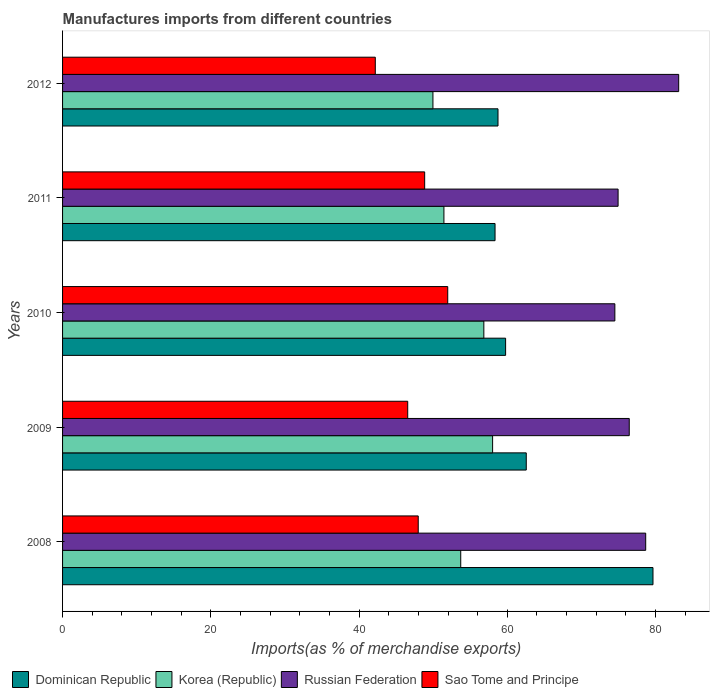How many groups of bars are there?
Make the answer very short. 5. How many bars are there on the 2nd tick from the top?
Make the answer very short. 4. How many bars are there on the 4th tick from the bottom?
Keep it short and to the point. 4. What is the label of the 2nd group of bars from the top?
Offer a terse response. 2011. In how many cases, is the number of bars for a given year not equal to the number of legend labels?
Offer a very short reply. 0. What is the percentage of imports to different countries in Korea (Republic) in 2012?
Ensure brevity in your answer.  49.97. Across all years, what is the maximum percentage of imports to different countries in Sao Tome and Principe?
Provide a short and direct response. 51.97. Across all years, what is the minimum percentage of imports to different countries in Russian Federation?
Make the answer very short. 74.51. In which year was the percentage of imports to different countries in Sao Tome and Principe maximum?
Ensure brevity in your answer.  2010. In which year was the percentage of imports to different countries in Korea (Republic) minimum?
Offer a terse response. 2012. What is the total percentage of imports to different countries in Korea (Republic) in the graph?
Provide a short and direct response. 269.99. What is the difference between the percentage of imports to different countries in Russian Federation in 2009 and that in 2010?
Your answer should be very brief. 1.94. What is the difference between the percentage of imports to different countries in Russian Federation in 2011 and the percentage of imports to different countries in Dominican Republic in 2008?
Give a very brief answer. -4.71. What is the average percentage of imports to different countries in Russian Federation per year?
Offer a very short reply. 77.54. In the year 2009, what is the difference between the percentage of imports to different countries in Korea (Republic) and percentage of imports to different countries in Sao Tome and Principe?
Offer a terse response. 11.45. What is the ratio of the percentage of imports to different countries in Dominican Republic in 2011 to that in 2012?
Provide a succinct answer. 0.99. What is the difference between the highest and the second highest percentage of imports to different countries in Dominican Republic?
Your answer should be compact. 17.1. What is the difference between the highest and the lowest percentage of imports to different countries in Korea (Republic)?
Your answer should be compact. 8.05. What does the 2nd bar from the top in 2011 represents?
Your answer should be compact. Russian Federation. What does the 3rd bar from the bottom in 2011 represents?
Your answer should be compact. Russian Federation. What is the difference between two consecutive major ticks on the X-axis?
Keep it short and to the point. 20. Are the values on the major ticks of X-axis written in scientific E-notation?
Your answer should be very brief. No. Does the graph contain any zero values?
Ensure brevity in your answer.  No. How many legend labels are there?
Provide a short and direct response. 4. What is the title of the graph?
Your answer should be very brief. Manufactures imports from different countries. What is the label or title of the X-axis?
Give a very brief answer. Imports(as % of merchandise exports). What is the label or title of the Y-axis?
Offer a terse response. Years. What is the Imports(as % of merchandise exports) of Dominican Republic in 2008?
Offer a very short reply. 79.66. What is the Imports(as % of merchandise exports) in Korea (Republic) in 2008?
Give a very brief answer. 53.72. What is the Imports(as % of merchandise exports) of Russian Federation in 2008?
Provide a short and direct response. 78.67. What is the Imports(as % of merchandise exports) of Sao Tome and Principe in 2008?
Your answer should be compact. 47.98. What is the Imports(as % of merchandise exports) in Dominican Republic in 2009?
Give a very brief answer. 62.56. What is the Imports(as % of merchandise exports) of Korea (Republic) in 2009?
Give a very brief answer. 58.02. What is the Imports(as % of merchandise exports) of Russian Federation in 2009?
Ensure brevity in your answer.  76.45. What is the Imports(as % of merchandise exports) in Sao Tome and Principe in 2009?
Ensure brevity in your answer.  46.57. What is the Imports(as % of merchandise exports) in Dominican Republic in 2010?
Keep it short and to the point. 59.77. What is the Imports(as % of merchandise exports) in Korea (Republic) in 2010?
Your answer should be very brief. 56.84. What is the Imports(as % of merchandise exports) of Russian Federation in 2010?
Your response must be concise. 74.51. What is the Imports(as % of merchandise exports) in Sao Tome and Principe in 2010?
Keep it short and to the point. 51.97. What is the Imports(as % of merchandise exports) in Dominican Republic in 2011?
Provide a short and direct response. 58.35. What is the Imports(as % of merchandise exports) of Korea (Republic) in 2011?
Provide a succinct answer. 51.45. What is the Imports(as % of merchandise exports) of Russian Federation in 2011?
Make the answer very short. 74.95. What is the Imports(as % of merchandise exports) in Sao Tome and Principe in 2011?
Offer a terse response. 48.85. What is the Imports(as % of merchandise exports) in Dominican Republic in 2012?
Offer a very short reply. 58.75. What is the Imports(as % of merchandise exports) in Korea (Republic) in 2012?
Offer a terse response. 49.97. What is the Imports(as % of merchandise exports) of Russian Federation in 2012?
Offer a terse response. 83.12. What is the Imports(as % of merchandise exports) of Sao Tome and Principe in 2012?
Provide a succinct answer. 42.19. Across all years, what is the maximum Imports(as % of merchandise exports) in Dominican Republic?
Offer a very short reply. 79.66. Across all years, what is the maximum Imports(as % of merchandise exports) in Korea (Republic)?
Your answer should be compact. 58.02. Across all years, what is the maximum Imports(as % of merchandise exports) of Russian Federation?
Your answer should be very brief. 83.12. Across all years, what is the maximum Imports(as % of merchandise exports) in Sao Tome and Principe?
Offer a terse response. 51.97. Across all years, what is the minimum Imports(as % of merchandise exports) of Dominican Republic?
Provide a short and direct response. 58.35. Across all years, what is the minimum Imports(as % of merchandise exports) in Korea (Republic)?
Keep it short and to the point. 49.97. Across all years, what is the minimum Imports(as % of merchandise exports) in Russian Federation?
Your answer should be compact. 74.51. Across all years, what is the minimum Imports(as % of merchandise exports) in Sao Tome and Principe?
Offer a very short reply. 42.19. What is the total Imports(as % of merchandise exports) of Dominican Republic in the graph?
Your answer should be compact. 319.08. What is the total Imports(as % of merchandise exports) in Korea (Republic) in the graph?
Make the answer very short. 269.99. What is the total Imports(as % of merchandise exports) of Russian Federation in the graph?
Give a very brief answer. 387.71. What is the total Imports(as % of merchandise exports) of Sao Tome and Principe in the graph?
Provide a succinct answer. 237.56. What is the difference between the Imports(as % of merchandise exports) in Dominican Republic in 2008 and that in 2009?
Provide a short and direct response. 17.1. What is the difference between the Imports(as % of merchandise exports) of Korea (Republic) in 2008 and that in 2009?
Give a very brief answer. -4.3. What is the difference between the Imports(as % of merchandise exports) of Russian Federation in 2008 and that in 2009?
Make the answer very short. 2.22. What is the difference between the Imports(as % of merchandise exports) in Sao Tome and Principe in 2008 and that in 2009?
Make the answer very short. 1.42. What is the difference between the Imports(as % of merchandise exports) in Dominican Republic in 2008 and that in 2010?
Give a very brief answer. 19.88. What is the difference between the Imports(as % of merchandise exports) in Korea (Republic) in 2008 and that in 2010?
Your response must be concise. -3.12. What is the difference between the Imports(as % of merchandise exports) of Russian Federation in 2008 and that in 2010?
Give a very brief answer. 4.16. What is the difference between the Imports(as % of merchandise exports) of Sao Tome and Principe in 2008 and that in 2010?
Your answer should be very brief. -3.98. What is the difference between the Imports(as % of merchandise exports) of Dominican Republic in 2008 and that in 2011?
Your answer should be very brief. 21.31. What is the difference between the Imports(as % of merchandise exports) of Korea (Republic) in 2008 and that in 2011?
Your answer should be very brief. 2.27. What is the difference between the Imports(as % of merchandise exports) in Russian Federation in 2008 and that in 2011?
Provide a succinct answer. 3.73. What is the difference between the Imports(as % of merchandise exports) of Sao Tome and Principe in 2008 and that in 2011?
Your answer should be compact. -0.87. What is the difference between the Imports(as % of merchandise exports) in Dominican Republic in 2008 and that in 2012?
Your answer should be very brief. 20.91. What is the difference between the Imports(as % of merchandise exports) of Korea (Republic) in 2008 and that in 2012?
Provide a succinct answer. 3.75. What is the difference between the Imports(as % of merchandise exports) in Russian Federation in 2008 and that in 2012?
Your response must be concise. -4.45. What is the difference between the Imports(as % of merchandise exports) in Sao Tome and Principe in 2008 and that in 2012?
Offer a terse response. 5.79. What is the difference between the Imports(as % of merchandise exports) in Dominican Republic in 2009 and that in 2010?
Give a very brief answer. 2.79. What is the difference between the Imports(as % of merchandise exports) of Korea (Republic) in 2009 and that in 2010?
Make the answer very short. 1.18. What is the difference between the Imports(as % of merchandise exports) of Russian Federation in 2009 and that in 2010?
Your answer should be compact. 1.94. What is the difference between the Imports(as % of merchandise exports) of Dominican Republic in 2009 and that in 2011?
Provide a short and direct response. 4.21. What is the difference between the Imports(as % of merchandise exports) of Korea (Republic) in 2009 and that in 2011?
Offer a terse response. 6.57. What is the difference between the Imports(as % of merchandise exports) in Russian Federation in 2009 and that in 2011?
Provide a short and direct response. 1.5. What is the difference between the Imports(as % of merchandise exports) of Sao Tome and Principe in 2009 and that in 2011?
Ensure brevity in your answer.  -2.29. What is the difference between the Imports(as % of merchandise exports) in Dominican Republic in 2009 and that in 2012?
Your answer should be compact. 3.81. What is the difference between the Imports(as % of merchandise exports) of Korea (Republic) in 2009 and that in 2012?
Provide a short and direct response. 8.05. What is the difference between the Imports(as % of merchandise exports) of Russian Federation in 2009 and that in 2012?
Your answer should be very brief. -6.67. What is the difference between the Imports(as % of merchandise exports) in Sao Tome and Principe in 2009 and that in 2012?
Your response must be concise. 4.37. What is the difference between the Imports(as % of merchandise exports) of Dominican Republic in 2010 and that in 2011?
Your response must be concise. 1.42. What is the difference between the Imports(as % of merchandise exports) of Korea (Republic) in 2010 and that in 2011?
Your response must be concise. 5.39. What is the difference between the Imports(as % of merchandise exports) of Russian Federation in 2010 and that in 2011?
Provide a succinct answer. -0.44. What is the difference between the Imports(as % of merchandise exports) of Sao Tome and Principe in 2010 and that in 2011?
Your answer should be very brief. 3.11. What is the difference between the Imports(as % of merchandise exports) of Dominican Republic in 2010 and that in 2012?
Ensure brevity in your answer.  1.03. What is the difference between the Imports(as % of merchandise exports) of Korea (Republic) in 2010 and that in 2012?
Ensure brevity in your answer.  6.87. What is the difference between the Imports(as % of merchandise exports) of Russian Federation in 2010 and that in 2012?
Your response must be concise. -8.61. What is the difference between the Imports(as % of merchandise exports) of Sao Tome and Principe in 2010 and that in 2012?
Give a very brief answer. 9.77. What is the difference between the Imports(as % of merchandise exports) of Dominican Republic in 2011 and that in 2012?
Offer a terse response. -0.4. What is the difference between the Imports(as % of merchandise exports) of Korea (Republic) in 2011 and that in 2012?
Provide a succinct answer. 1.48. What is the difference between the Imports(as % of merchandise exports) in Russian Federation in 2011 and that in 2012?
Make the answer very short. -8.18. What is the difference between the Imports(as % of merchandise exports) in Sao Tome and Principe in 2011 and that in 2012?
Your answer should be very brief. 6.66. What is the difference between the Imports(as % of merchandise exports) of Dominican Republic in 2008 and the Imports(as % of merchandise exports) of Korea (Republic) in 2009?
Give a very brief answer. 21.64. What is the difference between the Imports(as % of merchandise exports) in Dominican Republic in 2008 and the Imports(as % of merchandise exports) in Russian Federation in 2009?
Your response must be concise. 3.2. What is the difference between the Imports(as % of merchandise exports) in Dominican Republic in 2008 and the Imports(as % of merchandise exports) in Sao Tome and Principe in 2009?
Your response must be concise. 33.09. What is the difference between the Imports(as % of merchandise exports) in Korea (Republic) in 2008 and the Imports(as % of merchandise exports) in Russian Federation in 2009?
Your answer should be compact. -22.73. What is the difference between the Imports(as % of merchandise exports) in Korea (Republic) in 2008 and the Imports(as % of merchandise exports) in Sao Tome and Principe in 2009?
Give a very brief answer. 7.15. What is the difference between the Imports(as % of merchandise exports) of Russian Federation in 2008 and the Imports(as % of merchandise exports) of Sao Tome and Principe in 2009?
Your answer should be compact. 32.11. What is the difference between the Imports(as % of merchandise exports) in Dominican Republic in 2008 and the Imports(as % of merchandise exports) in Korea (Republic) in 2010?
Provide a short and direct response. 22.82. What is the difference between the Imports(as % of merchandise exports) in Dominican Republic in 2008 and the Imports(as % of merchandise exports) in Russian Federation in 2010?
Provide a succinct answer. 5.14. What is the difference between the Imports(as % of merchandise exports) of Dominican Republic in 2008 and the Imports(as % of merchandise exports) of Sao Tome and Principe in 2010?
Offer a terse response. 27.69. What is the difference between the Imports(as % of merchandise exports) of Korea (Republic) in 2008 and the Imports(as % of merchandise exports) of Russian Federation in 2010?
Your response must be concise. -20.79. What is the difference between the Imports(as % of merchandise exports) in Korea (Republic) in 2008 and the Imports(as % of merchandise exports) in Sao Tome and Principe in 2010?
Keep it short and to the point. 1.75. What is the difference between the Imports(as % of merchandise exports) in Russian Federation in 2008 and the Imports(as % of merchandise exports) in Sao Tome and Principe in 2010?
Keep it short and to the point. 26.71. What is the difference between the Imports(as % of merchandise exports) of Dominican Republic in 2008 and the Imports(as % of merchandise exports) of Korea (Republic) in 2011?
Ensure brevity in your answer.  28.2. What is the difference between the Imports(as % of merchandise exports) in Dominican Republic in 2008 and the Imports(as % of merchandise exports) in Russian Federation in 2011?
Ensure brevity in your answer.  4.71. What is the difference between the Imports(as % of merchandise exports) of Dominican Republic in 2008 and the Imports(as % of merchandise exports) of Sao Tome and Principe in 2011?
Your answer should be compact. 30.8. What is the difference between the Imports(as % of merchandise exports) in Korea (Republic) in 2008 and the Imports(as % of merchandise exports) in Russian Federation in 2011?
Your answer should be compact. -21.23. What is the difference between the Imports(as % of merchandise exports) in Korea (Republic) in 2008 and the Imports(as % of merchandise exports) in Sao Tome and Principe in 2011?
Ensure brevity in your answer.  4.87. What is the difference between the Imports(as % of merchandise exports) of Russian Federation in 2008 and the Imports(as % of merchandise exports) of Sao Tome and Principe in 2011?
Offer a very short reply. 29.82. What is the difference between the Imports(as % of merchandise exports) of Dominican Republic in 2008 and the Imports(as % of merchandise exports) of Korea (Republic) in 2012?
Make the answer very short. 29.69. What is the difference between the Imports(as % of merchandise exports) of Dominican Republic in 2008 and the Imports(as % of merchandise exports) of Russian Federation in 2012?
Provide a succinct answer. -3.47. What is the difference between the Imports(as % of merchandise exports) in Dominican Republic in 2008 and the Imports(as % of merchandise exports) in Sao Tome and Principe in 2012?
Your answer should be very brief. 37.46. What is the difference between the Imports(as % of merchandise exports) of Korea (Republic) in 2008 and the Imports(as % of merchandise exports) of Russian Federation in 2012?
Your response must be concise. -29.4. What is the difference between the Imports(as % of merchandise exports) of Korea (Republic) in 2008 and the Imports(as % of merchandise exports) of Sao Tome and Principe in 2012?
Make the answer very short. 11.53. What is the difference between the Imports(as % of merchandise exports) of Russian Federation in 2008 and the Imports(as % of merchandise exports) of Sao Tome and Principe in 2012?
Keep it short and to the point. 36.48. What is the difference between the Imports(as % of merchandise exports) in Dominican Republic in 2009 and the Imports(as % of merchandise exports) in Korea (Republic) in 2010?
Ensure brevity in your answer.  5.72. What is the difference between the Imports(as % of merchandise exports) in Dominican Republic in 2009 and the Imports(as % of merchandise exports) in Russian Federation in 2010?
Your answer should be very brief. -11.95. What is the difference between the Imports(as % of merchandise exports) of Dominican Republic in 2009 and the Imports(as % of merchandise exports) of Sao Tome and Principe in 2010?
Your answer should be very brief. 10.59. What is the difference between the Imports(as % of merchandise exports) in Korea (Republic) in 2009 and the Imports(as % of merchandise exports) in Russian Federation in 2010?
Your response must be concise. -16.49. What is the difference between the Imports(as % of merchandise exports) in Korea (Republic) in 2009 and the Imports(as % of merchandise exports) in Sao Tome and Principe in 2010?
Your answer should be very brief. 6.05. What is the difference between the Imports(as % of merchandise exports) in Russian Federation in 2009 and the Imports(as % of merchandise exports) in Sao Tome and Principe in 2010?
Provide a succinct answer. 24.49. What is the difference between the Imports(as % of merchandise exports) in Dominican Republic in 2009 and the Imports(as % of merchandise exports) in Korea (Republic) in 2011?
Your answer should be compact. 11.11. What is the difference between the Imports(as % of merchandise exports) in Dominican Republic in 2009 and the Imports(as % of merchandise exports) in Russian Federation in 2011?
Make the answer very short. -12.39. What is the difference between the Imports(as % of merchandise exports) in Dominican Republic in 2009 and the Imports(as % of merchandise exports) in Sao Tome and Principe in 2011?
Your response must be concise. 13.71. What is the difference between the Imports(as % of merchandise exports) in Korea (Republic) in 2009 and the Imports(as % of merchandise exports) in Russian Federation in 2011?
Keep it short and to the point. -16.93. What is the difference between the Imports(as % of merchandise exports) in Korea (Republic) in 2009 and the Imports(as % of merchandise exports) in Sao Tome and Principe in 2011?
Give a very brief answer. 9.17. What is the difference between the Imports(as % of merchandise exports) in Russian Federation in 2009 and the Imports(as % of merchandise exports) in Sao Tome and Principe in 2011?
Provide a short and direct response. 27.6. What is the difference between the Imports(as % of merchandise exports) in Dominican Republic in 2009 and the Imports(as % of merchandise exports) in Korea (Republic) in 2012?
Keep it short and to the point. 12.59. What is the difference between the Imports(as % of merchandise exports) of Dominican Republic in 2009 and the Imports(as % of merchandise exports) of Russian Federation in 2012?
Keep it short and to the point. -20.56. What is the difference between the Imports(as % of merchandise exports) of Dominican Republic in 2009 and the Imports(as % of merchandise exports) of Sao Tome and Principe in 2012?
Keep it short and to the point. 20.37. What is the difference between the Imports(as % of merchandise exports) in Korea (Republic) in 2009 and the Imports(as % of merchandise exports) in Russian Federation in 2012?
Provide a short and direct response. -25.1. What is the difference between the Imports(as % of merchandise exports) in Korea (Republic) in 2009 and the Imports(as % of merchandise exports) in Sao Tome and Principe in 2012?
Provide a succinct answer. 15.83. What is the difference between the Imports(as % of merchandise exports) of Russian Federation in 2009 and the Imports(as % of merchandise exports) of Sao Tome and Principe in 2012?
Your answer should be very brief. 34.26. What is the difference between the Imports(as % of merchandise exports) in Dominican Republic in 2010 and the Imports(as % of merchandise exports) in Korea (Republic) in 2011?
Offer a very short reply. 8.32. What is the difference between the Imports(as % of merchandise exports) of Dominican Republic in 2010 and the Imports(as % of merchandise exports) of Russian Federation in 2011?
Offer a terse response. -15.18. What is the difference between the Imports(as % of merchandise exports) in Dominican Republic in 2010 and the Imports(as % of merchandise exports) in Sao Tome and Principe in 2011?
Provide a succinct answer. 10.92. What is the difference between the Imports(as % of merchandise exports) in Korea (Republic) in 2010 and the Imports(as % of merchandise exports) in Russian Federation in 2011?
Give a very brief answer. -18.11. What is the difference between the Imports(as % of merchandise exports) of Korea (Republic) in 2010 and the Imports(as % of merchandise exports) of Sao Tome and Principe in 2011?
Offer a terse response. 7.98. What is the difference between the Imports(as % of merchandise exports) of Russian Federation in 2010 and the Imports(as % of merchandise exports) of Sao Tome and Principe in 2011?
Give a very brief answer. 25.66. What is the difference between the Imports(as % of merchandise exports) in Dominican Republic in 2010 and the Imports(as % of merchandise exports) in Korea (Republic) in 2012?
Give a very brief answer. 9.8. What is the difference between the Imports(as % of merchandise exports) of Dominican Republic in 2010 and the Imports(as % of merchandise exports) of Russian Federation in 2012?
Give a very brief answer. -23.35. What is the difference between the Imports(as % of merchandise exports) in Dominican Republic in 2010 and the Imports(as % of merchandise exports) in Sao Tome and Principe in 2012?
Offer a very short reply. 17.58. What is the difference between the Imports(as % of merchandise exports) of Korea (Republic) in 2010 and the Imports(as % of merchandise exports) of Russian Federation in 2012?
Your answer should be compact. -26.29. What is the difference between the Imports(as % of merchandise exports) in Korea (Republic) in 2010 and the Imports(as % of merchandise exports) in Sao Tome and Principe in 2012?
Give a very brief answer. 14.65. What is the difference between the Imports(as % of merchandise exports) in Russian Federation in 2010 and the Imports(as % of merchandise exports) in Sao Tome and Principe in 2012?
Offer a very short reply. 32.32. What is the difference between the Imports(as % of merchandise exports) in Dominican Republic in 2011 and the Imports(as % of merchandise exports) in Korea (Republic) in 2012?
Offer a terse response. 8.38. What is the difference between the Imports(as % of merchandise exports) in Dominican Republic in 2011 and the Imports(as % of merchandise exports) in Russian Federation in 2012?
Your answer should be very brief. -24.78. What is the difference between the Imports(as % of merchandise exports) in Dominican Republic in 2011 and the Imports(as % of merchandise exports) in Sao Tome and Principe in 2012?
Your response must be concise. 16.16. What is the difference between the Imports(as % of merchandise exports) of Korea (Republic) in 2011 and the Imports(as % of merchandise exports) of Russian Federation in 2012?
Give a very brief answer. -31.67. What is the difference between the Imports(as % of merchandise exports) in Korea (Republic) in 2011 and the Imports(as % of merchandise exports) in Sao Tome and Principe in 2012?
Your answer should be very brief. 9.26. What is the difference between the Imports(as % of merchandise exports) in Russian Federation in 2011 and the Imports(as % of merchandise exports) in Sao Tome and Principe in 2012?
Provide a short and direct response. 32.76. What is the average Imports(as % of merchandise exports) of Dominican Republic per year?
Your answer should be compact. 63.82. What is the average Imports(as % of merchandise exports) of Korea (Republic) per year?
Offer a very short reply. 54. What is the average Imports(as % of merchandise exports) of Russian Federation per year?
Make the answer very short. 77.54. What is the average Imports(as % of merchandise exports) of Sao Tome and Principe per year?
Your answer should be very brief. 47.51. In the year 2008, what is the difference between the Imports(as % of merchandise exports) in Dominican Republic and Imports(as % of merchandise exports) in Korea (Republic)?
Make the answer very short. 25.94. In the year 2008, what is the difference between the Imports(as % of merchandise exports) in Dominican Republic and Imports(as % of merchandise exports) in Russian Federation?
Provide a succinct answer. 0.98. In the year 2008, what is the difference between the Imports(as % of merchandise exports) in Dominican Republic and Imports(as % of merchandise exports) in Sao Tome and Principe?
Offer a terse response. 31.67. In the year 2008, what is the difference between the Imports(as % of merchandise exports) in Korea (Republic) and Imports(as % of merchandise exports) in Russian Federation?
Offer a terse response. -24.96. In the year 2008, what is the difference between the Imports(as % of merchandise exports) of Korea (Republic) and Imports(as % of merchandise exports) of Sao Tome and Principe?
Provide a succinct answer. 5.73. In the year 2008, what is the difference between the Imports(as % of merchandise exports) of Russian Federation and Imports(as % of merchandise exports) of Sao Tome and Principe?
Give a very brief answer. 30.69. In the year 2009, what is the difference between the Imports(as % of merchandise exports) of Dominican Republic and Imports(as % of merchandise exports) of Korea (Republic)?
Your answer should be very brief. 4.54. In the year 2009, what is the difference between the Imports(as % of merchandise exports) in Dominican Republic and Imports(as % of merchandise exports) in Russian Federation?
Keep it short and to the point. -13.89. In the year 2009, what is the difference between the Imports(as % of merchandise exports) in Dominican Republic and Imports(as % of merchandise exports) in Sao Tome and Principe?
Keep it short and to the point. 15.99. In the year 2009, what is the difference between the Imports(as % of merchandise exports) in Korea (Republic) and Imports(as % of merchandise exports) in Russian Federation?
Make the answer very short. -18.43. In the year 2009, what is the difference between the Imports(as % of merchandise exports) in Korea (Republic) and Imports(as % of merchandise exports) in Sao Tome and Principe?
Make the answer very short. 11.45. In the year 2009, what is the difference between the Imports(as % of merchandise exports) of Russian Federation and Imports(as % of merchandise exports) of Sao Tome and Principe?
Provide a short and direct response. 29.89. In the year 2010, what is the difference between the Imports(as % of merchandise exports) of Dominican Republic and Imports(as % of merchandise exports) of Korea (Republic)?
Provide a short and direct response. 2.94. In the year 2010, what is the difference between the Imports(as % of merchandise exports) of Dominican Republic and Imports(as % of merchandise exports) of Russian Federation?
Your response must be concise. -14.74. In the year 2010, what is the difference between the Imports(as % of merchandise exports) of Dominican Republic and Imports(as % of merchandise exports) of Sao Tome and Principe?
Your response must be concise. 7.81. In the year 2010, what is the difference between the Imports(as % of merchandise exports) of Korea (Republic) and Imports(as % of merchandise exports) of Russian Federation?
Your response must be concise. -17.67. In the year 2010, what is the difference between the Imports(as % of merchandise exports) in Korea (Republic) and Imports(as % of merchandise exports) in Sao Tome and Principe?
Provide a short and direct response. 4.87. In the year 2010, what is the difference between the Imports(as % of merchandise exports) in Russian Federation and Imports(as % of merchandise exports) in Sao Tome and Principe?
Make the answer very short. 22.55. In the year 2011, what is the difference between the Imports(as % of merchandise exports) in Dominican Republic and Imports(as % of merchandise exports) in Korea (Republic)?
Offer a very short reply. 6.9. In the year 2011, what is the difference between the Imports(as % of merchandise exports) in Dominican Republic and Imports(as % of merchandise exports) in Russian Federation?
Make the answer very short. -16.6. In the year 2011, what is the difference between the Imports(as % of merchandise exports) of Dominican Republic and Imports(as % of merchandise exports) of Sao Tome and Principe?
Make the answer very short. 9.49. In the year 2011, what is the difference between the Imports(as % of merchandise exports) of Korea (Republic) and Imports(as % of merchandise exports) of Russian Federation?
Offer a very short reply. -23.5. In the year 2011, what is the difference between the Imports(as % of merchandise exports) of Korea (Republic) and Imports(as % of merchandise exports) of Sao Tome and Principe?
Ensure brevity in your answer.  2.6. In the year 2011, what is the difference between the Imports(as % of merchandise exports) of Russian Federation and Imports(as % of merchandise exports) of Sao Tome and Principe?
Ensure brevity in your answer.  26.1. In the year 2012, what is the difference between the Imports(as % of merchandise exports) of Dominican Republic and Imports(as % of merchandise exports) of Korea (Republic)?
Your answer should be compact. 8.78. In the year 2012, what is the difference between the Imports(as % of merchandise exports) of Dominican Republic and Imports(as % of merchandise exports) of Russian Federation?
Provide a short and direct response. -24.38. In the year 2012, what is the difference between the Imports(as % of merchandise exports) in Dominican Republic and Imports(as % of merchandise exports) in Sao Tome and Principe?
Your response must be concise. 16.56. In the year 2012, what is the difference between the Imports(as % of merchandise exports) in Korea (Republic) and Imports(as % of merchandise exports) in Russian Federation?
Your answer should be compact. -33.16. In the year 2012, what is the difference between the Imports(as % of merchandise exports) of Korea (Republic) and Imports(as % of merchandise exports) of Sao Tome and Principe?
Make the answer very short. 7.78. In the year 2012, what is the difference between the Imports(as % of merchandise exports) of Russian Federation and Imports(as % of merchandise exports) of Sao Tome and Principe?
Make the answer very short. 40.93. What is the ratio of the Imports(as % of merchandise exports) in Dominican Republic in 2008 to that in 2009?
Your response must be concise. 1.27. What is the ratio of the Imports(as % of merchandise exports) of Korea (Republic) in 2008 to that in 2009?
Provide a succinct answer. 0.93. What is the ratio of the Imports(as % of merchandise exports) in Russian Federation in 2008 to that in 2009?
Your answer should be compact. 1.03. What is the ratio of the Imports(as % of merchandise exports) in Sao Tome and Principe in 2008 to that in 2009?
Provide a succinct answer. 1.03. What is the ratio of the Imports(as % of merchandise exports) in Dominican Republic in 2008 to that in 2010?
Ensure brevity in your answer.  1.33. What is the ratio of the Imports(as % of merchandise exports) in Korea (Republic) in 2008 to that in 2010?
Provide a succinct answer. 0.95. What is the ratio of the Imports(as % of merchandise exports) in Russian Federation in 2008 to that in 2010?
Your response must be concise. 1.06. What is the ratio of the Imports(as % of merchandise exports) in Sao Tome and Principe in 2008 to that in 2010?
Offer a very short reply. 0.92. What is the ratio of the Imports(as % of merchandise exports) of Dominican Republic in 2008 to that in 2011?
Offer a terse response. 1.37. What is the ratio of the Imports(as % of merchandise exports) of Korea (Republic) in 2008 to that in 2011?
Ensure brevity in your answer.  1.04. What is the ratio of the Imports(as % of merchandise exports) of Russian Federation in 2008 to that in 2011?
Give a very brief answer. 1.05. What is the ratio of the Imports(as % of merchandise exports) in Sao Tome and Principe in 2008 to that in 2011?
Make the answer very short. 0.98. What is the ratio of the Imports(as % of merchandise exports) in Dominican Republic in 2008 to that in 2012?
Your answer should be very brief. 1.36. What is the ratio of the Imports(as % of merchandise exports) of Korea (Republic) in 2008 to that in 2012?
Your response must be concise. 1.08. What is the ratio of the Imports(as % of merchandise exports) of Russian Federation in 2008 to that in 2012?
Make the answer very short. 0.95. What is the ratio of the Imports(as % of merchandise exports) in Sao Tome and Principe in 2008 to that in 2012?
Your response must be concise. 1.14. What is the ratio of the Imports(as % of merchandise exports) in Dominican Republic in 2009 to that in 2010?
Keep it short and to the point. 1.05. What is the ratio of the Imports(as % of merchandise exports) of Korea (Republic) in 2009 to that in 2010?
Make the answer very short. 1.02. What is the ratio of the Imports(as % of merchandise exports) in Russian Federation in 2009 to that in 2010?
Your answer should be very brief. 1.03. What is the ratio of the Imports(as % of merchandise exports) of Sao Tome and Principe in 2009 to that in 2010?
Offer a very short reply. 0.9. What is the ratio of the Imports(as % of merchandise exports) in Dominican Republic in 2009 to that in 2011?
Offer a very short reply. 1.07. What is the ratio of the Imports(as % of merchandise exports) in Korea (Republic) in 2009 to that in 2011?
Offer a terse response. 1.13. What is the ratio of the Imports(as % of merchandise exports) of Russian Federation in 2009 to that in 2011?
Provide a succinct answer. 1.02. What is the ratio of the Imports(as % of merchandise exports) of Sao Tome and Principe in 2009 to that in 2011?
Give a very brief answer. 0.95. What is the ratio of the Imports(as % of merchandise exports) in Dominican Republic in 2009 to that in 2012?
Provide a succinct answer. 1.06. What is the ratio of the Imports(as % of merchandise exports) in Korea (Republic) in 2009 to that in 2012?
Provide a succinct answer. 1.16. What is the ratio of the Imports(as % of merchandise exports) in Russian Federation in 2009 to that in 2012?
Ensure brevity in your answer.  0.92. What is the ratio of the Imports(as % of merchandise exports) in Sao Tome and Principe in 2009 to that in 2012?
Your response must be concise. 1.1. What is the ratio of the Imports(as % of merchandise exports) in Dominican Republic in 2010 to that in 2011?
Provide a succinct answer. 1.02. What is the ratio of the Imports(as % of merchandise exports) in Korea (Republic) in 2010 to that in 2011?
Provide a succinct answer. 1.1. What is the ratio of the Imports(as % of merchandise exports) in Russian Federation in 2010 to that in 2011?
Your answer should be compact. 0.99. What is the ratio of the Imports(as % of merchandise exports) of Sao Tome and Principe in 2010 to that in 2011?
Make the answer very short. 1.06. What is the ratio of the Imports(as % of merchandise exports) in Dominican Republic in 2010 to that in 2012?
Offer a terse response. 1.02. What is the ratio of the Imports(as % of merchandise exports) of Korea (Republic) in 2010 to that in 2012?
Give a very brief answer. 1.14. What is the ratio of the Imports(as % of merchandise exports) in Russian Federation in 2010 to that in 2012?
Offer a very short reply. 0.9. What is the ratio of the Imports(as % of merchandise exports) of Sao Tome and Principe in 2010 to that in 2012?
Offer a terse response. 1.23. What is the ratio of the Imports(as % of merchandise exports) of Dominican Republic in 2011 to that in 2012?
Offer a terse response. 0.99. What is the ratio of the Imports(as % of merchandise exports) in Korea (Republic) in 2011 to that in 2012?
Make the answer very short. 1.03. What is the ratio of the Imports(as % of merchandise exports) in Russian Federation in 2011 to that in 2012?
Keep it short and to the point. 0.9. What is the ratio of the Imports(as % of merchandise exports) of Sao Tome and Principe in 2011 to that in 2012?
Offer a very short reply. 1.16. What is the difference between the highest and the second highest Imports(as % of merchandise exports) in Dominican Republic?
Make the answer very short. 17.1. What is the difference between the highest and the second highest Imports(as % of merchandise exports) in Korea (Republic)?
Give a very brief answer. 1.18. What is the difference between the highest and the second highest Imports(as % of merchandise exports) of Russian Federation?
Your response must be concise. 4.45. What is the difference between the highest and the second highest Imports(as % of merchandise exports) of Sao Tome and Principe?
Give a very brief answer. 3.11. What is the difference between the highest and the lowest Imports(as % of merchandise exports) in Dominican Republic?
Make the answer very short. 21.31. What is the difference between the highest and the lowest Imports(as % of merchandise exports) of Korea (Republic)?
Provide a short and direct response. 8.05. What is the difference between the highest and the lowest Imports(as % of merchandise exports) in Russian Federation?
Give a very brief answer. 8.61. What is the difference between the highest and the lowest Imports(as % of merchandise exports) of Sao Tome and Principe?
Offer a terse response. 9.77. 